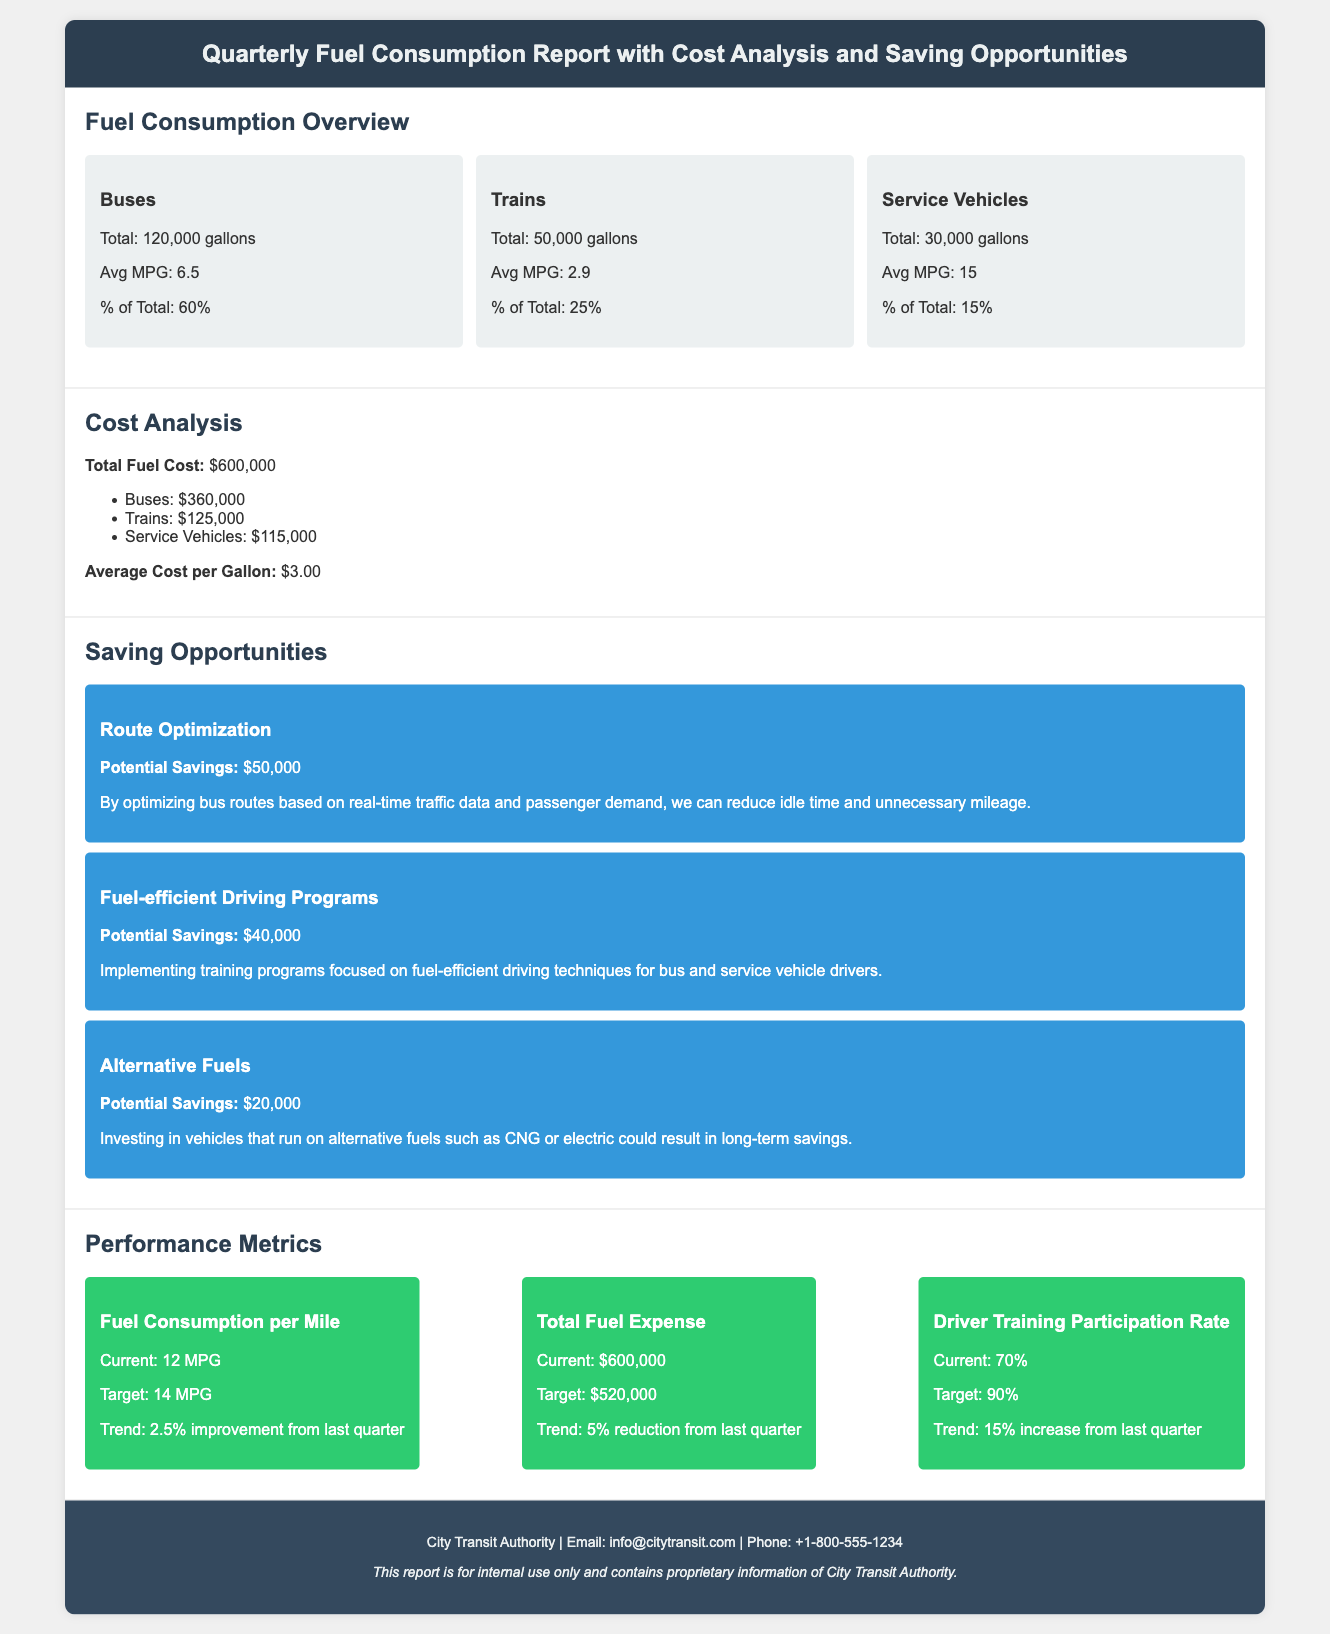What is the total fuel consumption for Buses? The document states that the total fuel consumption for Buses is 120,000 gallons.
Answer: 120,000 gallons What is the average cost per gallon of fuel? According to the document, the average cost per gallon is $3.00.
Answer: $3.00 What is the potential savings from Route Optimization? The document mentions that the potential savings from Route Optimization is $50,000.
Answer: $50,000 What is the target for Fuel Consumption per Mile? The target for Fuel Consumption per Mile is specified as 14 MPG in the document.
Answer: 14 MPG What is the current total fuel expense? The document reveals that the current total fuel expense is $600,000.
Answer: $600,000 How many gallons of fuel do Service Vehicles consume? The document indicates that Service Vehicles consume a total of 30,000 gallons.
Answer: 30,000 gallons What is the trend percentage for Total Fuel Expense reduction? The document states that the trend for Total Fuel Expense reduction is 5%.
Answer: 5% What is the participation rate for Driver Training? The document indicates that the current Driver Training Participation Rate is 70%.
Answer: 70% What is the potential savings from implementing Fuel-efficient Driving Programs? According to the document, the potential savings from Fuel-efficient Driving Programs is $40,000.
Answer: $40,000 